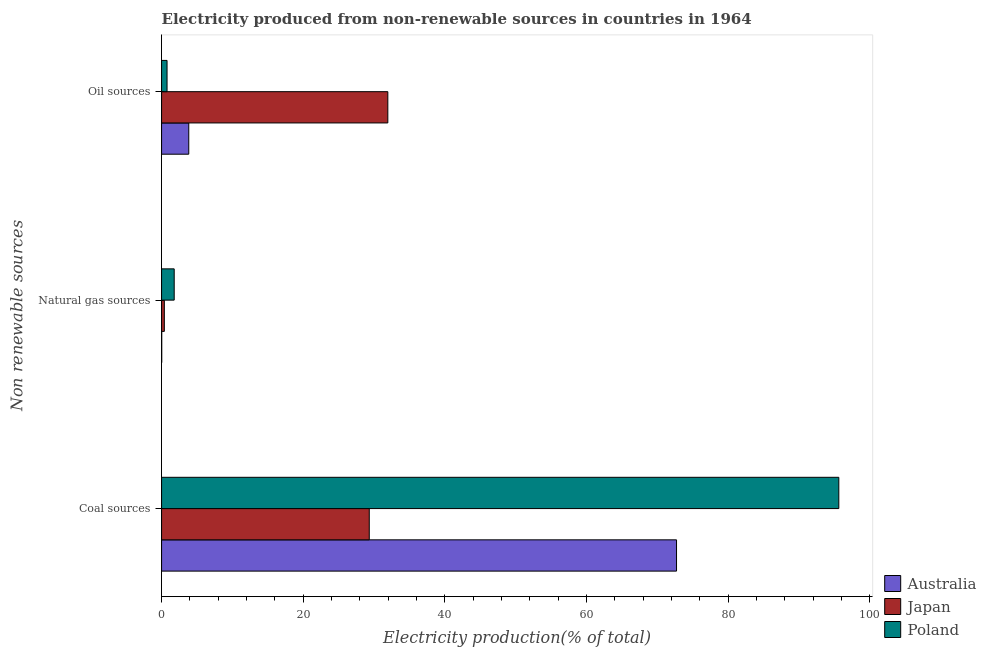How many different coloured bars are there?
Your response must be concise. 3. How many groups of bars are there?
Provide a short and direct response. 3. Are the number of bars on each tick of the Y-axis equal?
Keep it short and to the point. Yes. How many bars are there on the 3rd tick from the top?
Offer a terse response. 3. What is the label of the 2nd group of bars from the top?
Provide a short and direct response. Natural gas sources. What is the percentage of electricity produced by natural gas in Australia?
Your answer should be very brief. 0.02. Across all countries, what is the maximum percentage of electricity produced by natural gas?
Provide a short and direct response. 1.78. Across all countries, what is the minimum percentage of electricity produced by oil sources?
Ensure brevity in your answer.  0.77. In which country was the percentage of electricity produced by coal minimum?
Provide a short and direct response. Japan. What is the total percentage of electricity produced by natural gas in the graph?
Offer a very short reply. 2.2. What is the difference between the percentage of electricity produced by coal in Japan and that in Poland?
Your answer should be compact. -66.3. What is the difference between the percentage of electricity produced by coal in Australia and the percentage of electricity produced by natural gas in Poland?
Keep it short and to the point. 70.92. What is the average percentage of electricity produced by coal per country?
Make the answer very short. 65.88. What is the difference between the percentage of electricity produced by coal and percentage of electricity produced by oil sources in Japan?
Provide a short and direct response. -2.62. What is the ratio of the percentage of electricity produced by natural gas in Australia to that in Poland?
Your answer should be compact. 0.01. Is the percentage of electricity produced by oil sources in Japan less than that in Australia?
Offer a very short reply. No. What is the difference between the highest and the second highest percentage of electricity produced by natural gas?
Provide a succinct answer. 1.39. What is the difference between the highest and the lowest percentage of electricity produced by natural gas?
Provide a short and direct response. 1.76. In how many countries, is the percentage of electricity produced by coal greater than the average percentage of electricity produced by coal taken over all countries?
Provide a succinct answer. 2. Is the sum of the percentage of electricity produced by coal in Japan and Australia greater than the maximum percentage of electricity produced by oil sources across all countries?
Provide a short and direct response. Yes. What does the 1st bar from the top in Coal sources represents?
Provide a succinct answer. Poland. What does the 2nd bar from the bottom in Coal sources represents?
Provide a short and direct response. Japan. How many bars are there?
Give a very brief answer. 9. How many countries are there in the graph?
Your answer should be very brief. 3. What is the difference between two consecutive major ticks on the X-axis?
Your answer should be compact. 20. Are the values on the major ticks of X-axis written in scientific E-notation?
Keep it short and to the point. No. Does the graph contain any zero values?
Give a very brief answer. No. Does the graph contain grids?
Provide a short and direct response. No. Where does the legend appear in the graph?
Your answer should be very brief. Bottom right. What is the title of the graph?
Your answer should be compact. Electricity produced from non-renewable sources in countries in 1964. What is the label or title of the Y-axis?
Your response must be concise. Non renewable sources. What is the Electricity production(% of total) in Australia in Coal sources?
Keep it short and to the point. 72.71. What is the Electricity production(% of total) of Japan in Coal sources?
Your response must be concise. 29.32. What is the Electricity production(% of total) in Poland in Coal sources?
Your answer should be very brief. 95.62. What is the Electricity production(% of total) in Australia in Natural gas sources?
Provide a succinct answer. 0.02. What is the Electricity production(% of total) of Japan in Natural gas sources?
Offer a terse response. 0.39. What is the Electricity production(% of total) in Poland in Natural gas sources?
Offer a very short reply. 1.78. What is the Electricity production(% of total) in Australia in Oil sources?
Your answer should be very brief. 3.84. What is the Electricity production(% of total) in Japan in Oil sources?
Offer a terse response. 31.95. What is the Electricity production(% of total) of Poland in Oil sources?
Offer a terse response. 0.77. Across all Non renewable sources, what is the maximum Electricity production(% of total) of Australia?
Offer a very short reply. 72.71. Across all Non renewable sources, what is the maximum Electricity production(% of total) of Japan?
Offer a terse response. 31.95. Across all Non renewable sources, what is the maximum Electricity production(% of total) of Poland?
Provide a succinct answer. 95.62. Across all Non renewable sources, what is the minimum Electricity production(% of total) in Australia?
Your answer should be compact. 0.02. Across all Non renewable sources, what is the minimum Electricity production(% of total) of Japan?
Your response must be concise. 0.39. Across all Non renewable sources, what is the minimum Electricity production(% of total) of Poland?
Provide a succinct answer. 0.77. What is the total Electricity production(% of total) of Australia in the graph?
Give a very brief answer. 76.57. What is the total Electricity production(% of total) of Japan in the graph?
Make the answer very short. 61.66. What is the total Electricity production(% of total) in Poland in the graph?
Keep it short and to the point. 98.18. What is the difference between the Electricity production(% of total) of Australia in Coal sources and that in Natural gas sources?
Ensure brevity in your answer.  72.68. What is the difference between the Electricity production(% of total) in Japan in Coal sources and that in Natural gas sources?
Keep it short and to the point. 28.93. What is the difference between the Electricity production(% of total) in Poland in Coal sources and that in Natural gas sources?
Provide a short and direct response. 93.84. What is the difference between the Electricity production(% of total) of Australia in Coal sources and that in Oil sources?
Provide a succinct answer. 68.87. What is the difference between the Electricity production(% of total) of Japan in Coal sources and that in Oil sources?
Keep it short and to the point. -2.62. What is the difference between the Electricity production(% of total) of Poland in Coal sources and that in Oil sources?
Give a very brief answer. 94.85. What is the difference between the Electricity production(% of total) of Australia in Natural gas sources and that in Oil sources?
Offer a very short reply. -3.82. What is the difference between the Electricity production(% of total) in Japan in Natural gas sources and that in Oil sources?
Your response must be concise. -31.55. What is the difference between the Electricity production(% of total) of Australia in Coal sources and the Electricity production(% of total) of Japan in Natural gas sources?
Ensure brevity in your answer.  72.32. What is the difference between the Electricity production(% of total) of Australia in Coal sources and the Electricity production(% of total) of Poland in Natural gas sources?
Your response must be concise. 70.92. What is the difference between the Electricity production(% of total) of Japan in Coal sources and the Electricity production(% of total) of Poland in Natural gas sources?
Keep it short and to the point. 27.54. What is the difference between the Electricity production(% of total) in Australia in Coal sources and the Electricity production(% of total) in Japan in Oil sources?
Your answer should be compact. 40.76. What is the difference between the Electricity production(% of total) in Australia in Coal sources and the Electricity production(% of total) in Poland in Oil sources?
Ensure brevity in your answer.  71.93. What is the difference between the Electricity production(% of total) of Japan in Coal sources and the Electricity production(% of total) of Poland in Oil sources?
Give a very brief answer. 28.55. What is the difference between the Electricity production(% of total) of Australia in Natural gas sources and the Electricity production(% of total) of Japan in Oil sources?
Ensure brevity in your answer.  -31.92. What is the difference between the Electricity production(% of total) in Australia in Natural gas sources and the Electricity production(% of total) in Poland in Oil sources?
Offer a terse response. -0.75. What is the difference between the Electricity production(% of total) of Japan in Natural gas sources and the Electricity production(% of total) of Poland in Oil sources?
Your response must be concise. -0.38. What is the average Electricity production(% of total) in Australia per Non renewable sources?
Offer a very short reply. 25.52. What is the average Electricity production(% of total) of Japan per Non renewable sources?
Your response must be concise. 20.55. What is the average Electricity production(% of total) of Poland per Non renewable sources?
Ensure brevity in your answer.  32.73. What is the difference between the Electricity production(% of total) of Australia and Electricity production(% of total) of Japan in Coal sources?
Your answer should be very brief. 43.38. What is the difference between the Electricity production(% of total) in Australia and Electricity production(% of total) in Poland in Coal sources?
Your answer should be very brief. -22.91. What is the difference between the Electricity production(% of total) of Japan and Electricity production(% of total) of Poland in Coal sources?
Provide a short and direct response. -66.3. What is the difference between the Electricity production(% of total) in Australia and Electricity production(% of total) in Japan in Natural gas sources?
Your answer should be compact. -0.37. What is the difference between the Electricity production(% of total) in Australia and Electricity production(% of total) in Poland in Natural gas sources?
Keep it short and to the point. -1.76. What is the difference between the Electricity production(% of total) in Japan and Electricity production(% of total) in Poland in Natural gas sources?
Your response must be concise. -1.39. What is the difference between the Electricity production(% of total) in Australia and Electricity production(% of total) in Japan in Oil sources?
Give a very brief answer. -28.11. What is the difference between the Electricity production(% of total) in Australia and Electricity production(% of total) in Poland in Oil sources?
Keep it short and to the point. 3.07. What is the difference between the Electricity production(% of total) in Japan and Electricity production(% of total) in Poland in Oil sources?
Keep it short and to the point. 31.17. What is the ratio of the Electricity production(% of total) in Australia in Coal sources to that in Natural gas sources?
Ensure brevity in your answer.  3160.29. What is the ratio of the Electricity production(% of total) of Japan in Coal sources to that in Natural gas sources?
Give a very brief answer. 75.14. What is the ratio of the Electricity production(% of total) in Poland in Coal sources to that in Natural gas sources?
Offer a terse response. 53.61. What is the ratio of the Electricity production(% of total) in Australia in Coal sources to that in Oil sources?
Your response must be concise. 18.94. What is the ratio of the Electricity production(% of total) of Japan in Coal sources to that in Oil sources?
Provide a succinct answer. 0.92. What is the ratio of the Electricity production(% of total) in Poland in Coal sources to that in Oil sources?
Ensure brevity in your answer.  123.61. What is the ratio of the Electricity production(% of total) of Australia in Natural gas sources to that in Oil sources?
Provide a short and direct response. 0.01. What is the ratio of the Electricity production(% of total) in Japan in Natural gas sources to that in Oil sources?
Ensure brevity in your answer.  0.01. What is the ratio of the Electricity production(% of total) in Poland in Natural gas sources to that in Oil sources?
Provide a short and direct response. 2.31. What is the difference between the highest and the second highest Electricity production(% of total) of Australia?
Ensure brevity in your answer.  68.87. What is the difference between the highest and the second highest Electricity production(% of total) in Japan?
Offer a terse response. 2.62. What is the difference between the highest and the second highest Electricity production(% of total) in Poland?
Offer a terse response. 93.84. What is the difference between the highest and the lowest Electricity production(% of total) in Australia?
Your response must be concise. 72.68. What is the difference between the highest and the lowest Electricity production(% of total) in Japan?
Your response must be concise. 31.55. What is the difference between the highest and the lowest Electricity production(% of total) in Poland?
Give a very brief answer. 94.85. 